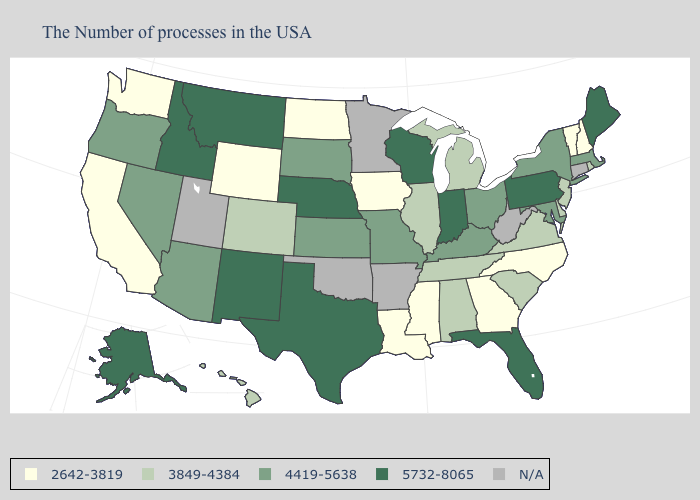What is the value of Massachusetts?
Give a very brief answer. 4419-5638. What is the value of Minnesota?
Give a very brief answer. N/A. Among the states that border New Jersey , does Delaware have the lowest value?
Write a very short answer. Yes. What is the highest value in the South ?
Concise answer only. 5732-8065. Among the states that border Nevada , which have the highest value?
Be succinct. Idaho. What is the value of Tennessee?
Quick response, please. 3849-4384. Does Maine have the lowest value in the Northeast?
Short answer required. No. What is the highest value in the Northeast ?
Short answer required. 5732-8065. What is the value of Idaho?
Concise answer only. 5732-8065. What is the value of West Virginia?
Give a very brief answer. N/A. Does Indiana have the lowest value in the USA?
Concise answer only. No. Does the map have missing data?
Answer briefly. Yes. Does Pennsylvania have the lowest value in the USA?
Give a very brief answer. No. 